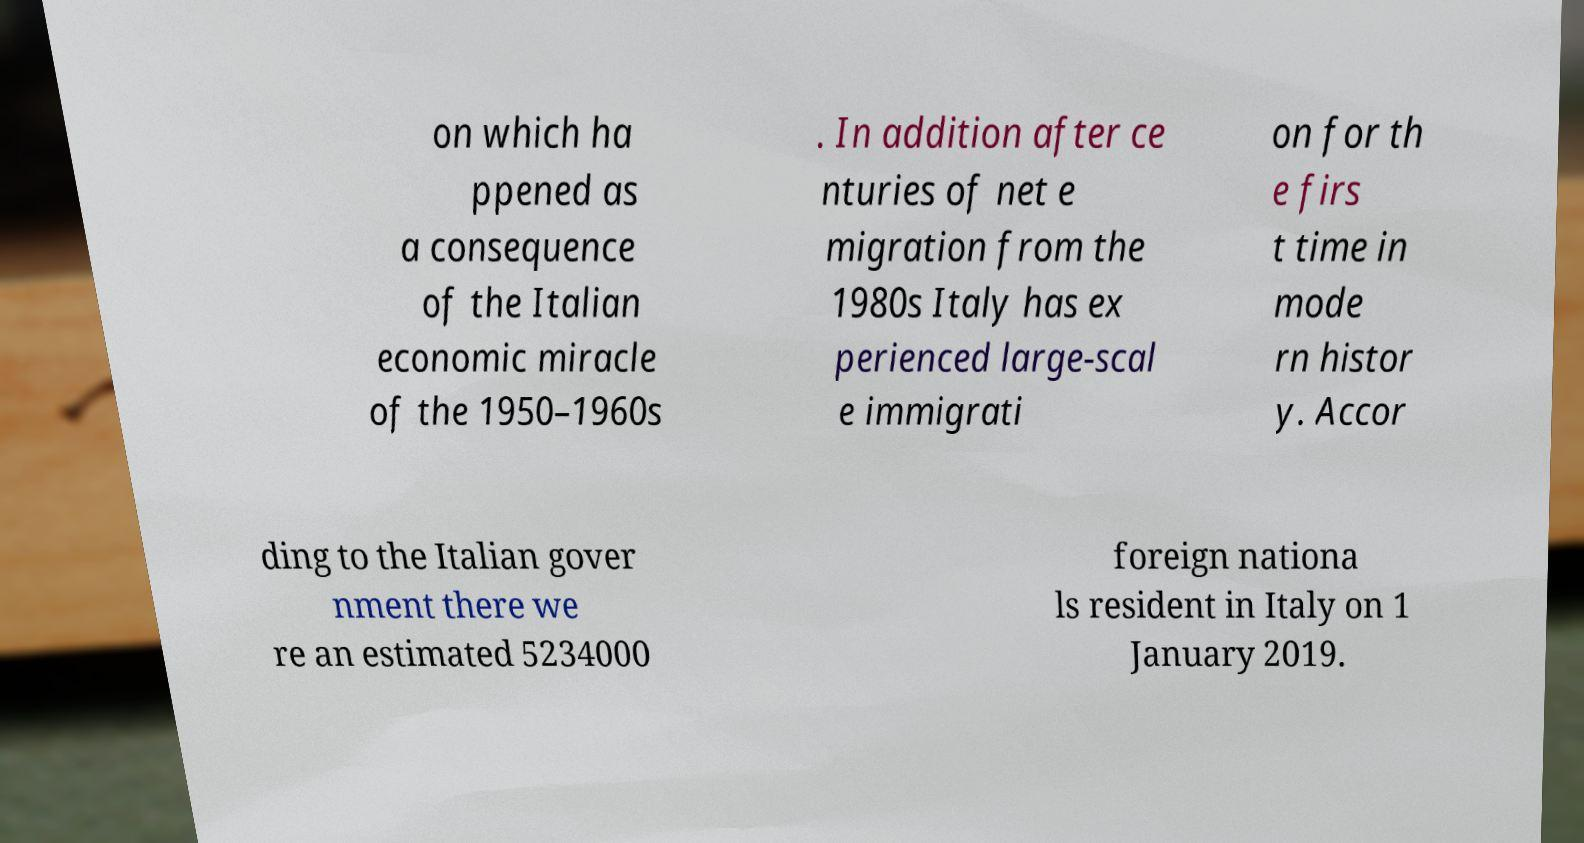I need the written content from this picture converted into text. Can you do that? on which ha ppened as a consequence of the Italian economic miracle of the 1950–1960s . In addition after ce nturies of net e migration from the 1980s Italy has ex perienced large-scal e immigrati on for th e firs t time in mode rn histor y. Accor ding to the Italian gover nment there we re an estimated 5234000 foreign nationa ls resident in Italy on 1 January 2019. 